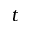<formula> <loc_0><loc_0><loc_500><loc_500>t</formula> 